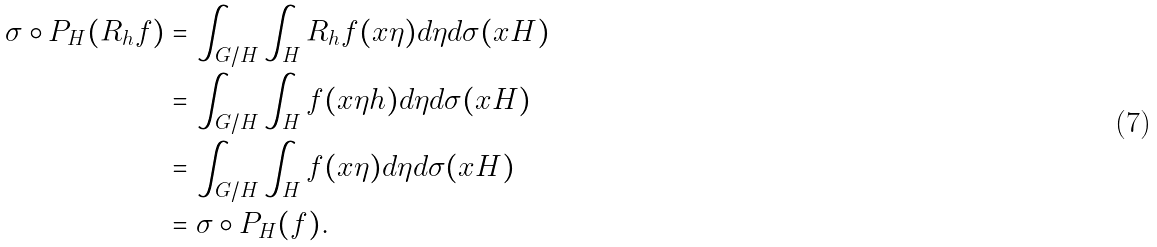Convert formula to latex. <formula><loc_0><loc_0><loc_500><loc_500>\sigma \circ P _ { H } ( R _ { h } f ) & = \int _ { G / H } { \int _ { H } { R _ { h } f ( x \eta ) d \eta d \sigma ( x H ) } } \\ & = \int _ { G / H } { \int _ { H } { f ( x \eta h ) d \eta d \sigma ( x H ) } } \\ & = \int _ { G / H } { \int _ { H } { f ( x \eta ) d \eta d \sigma ( x H ) } } \\ & = \sigma \circ P _ { H } ( f ) .</formula> 